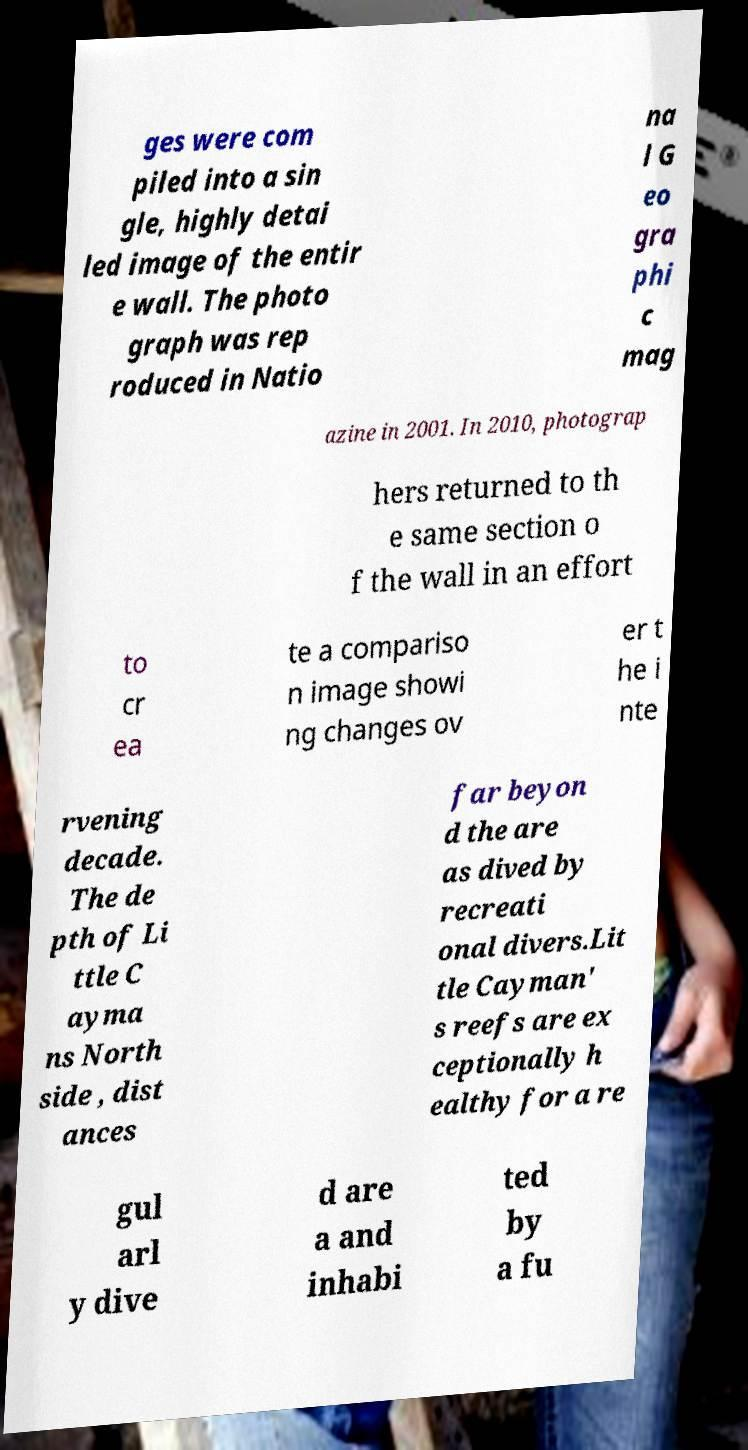For documentation purposes, I need the text within this image transcribed. Could you provide that? ges were com piled into a sin gle, highly detai led image of the entir e wall. The photo graph was rep roduced in Natio na l G eo gra phi c mag azine in 2001. In 2010, photograp hers returned to th e same section o f the wall in an effort to cr ea te a compariso n image showi ng changes ov er t he i nte rvening decade. The de pth of Li ttle C ayma ns North side , dist ances far beyon d the are as dived by recreati onal divers.Lit tle Cayman' s reefs are ex ceptionally h ealthy for a re gul arl y dive d are a and inhabi ted by a fu 